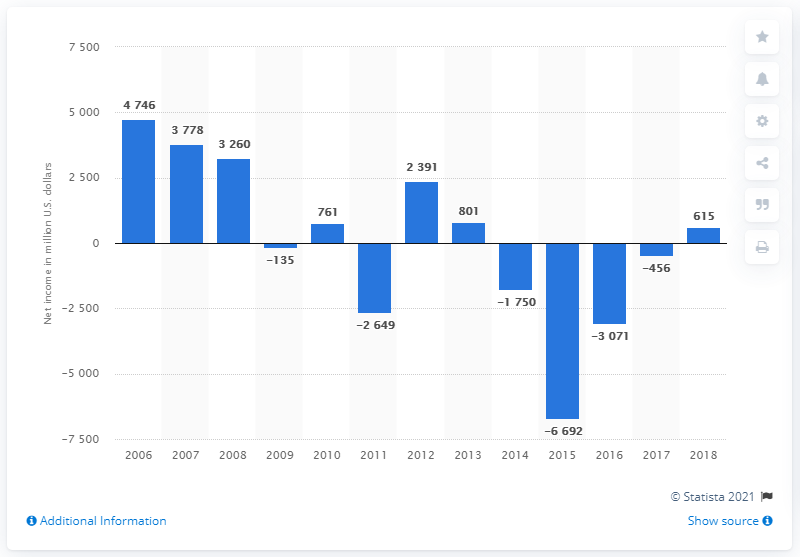Draw attention to some important aspects in this diagram. Anadarko Petroleum's net income in 2018 was approximately $615 million. 